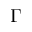<formula> <loc_0><loc_0><loc_500><loc_500>\Gamma</formula> 